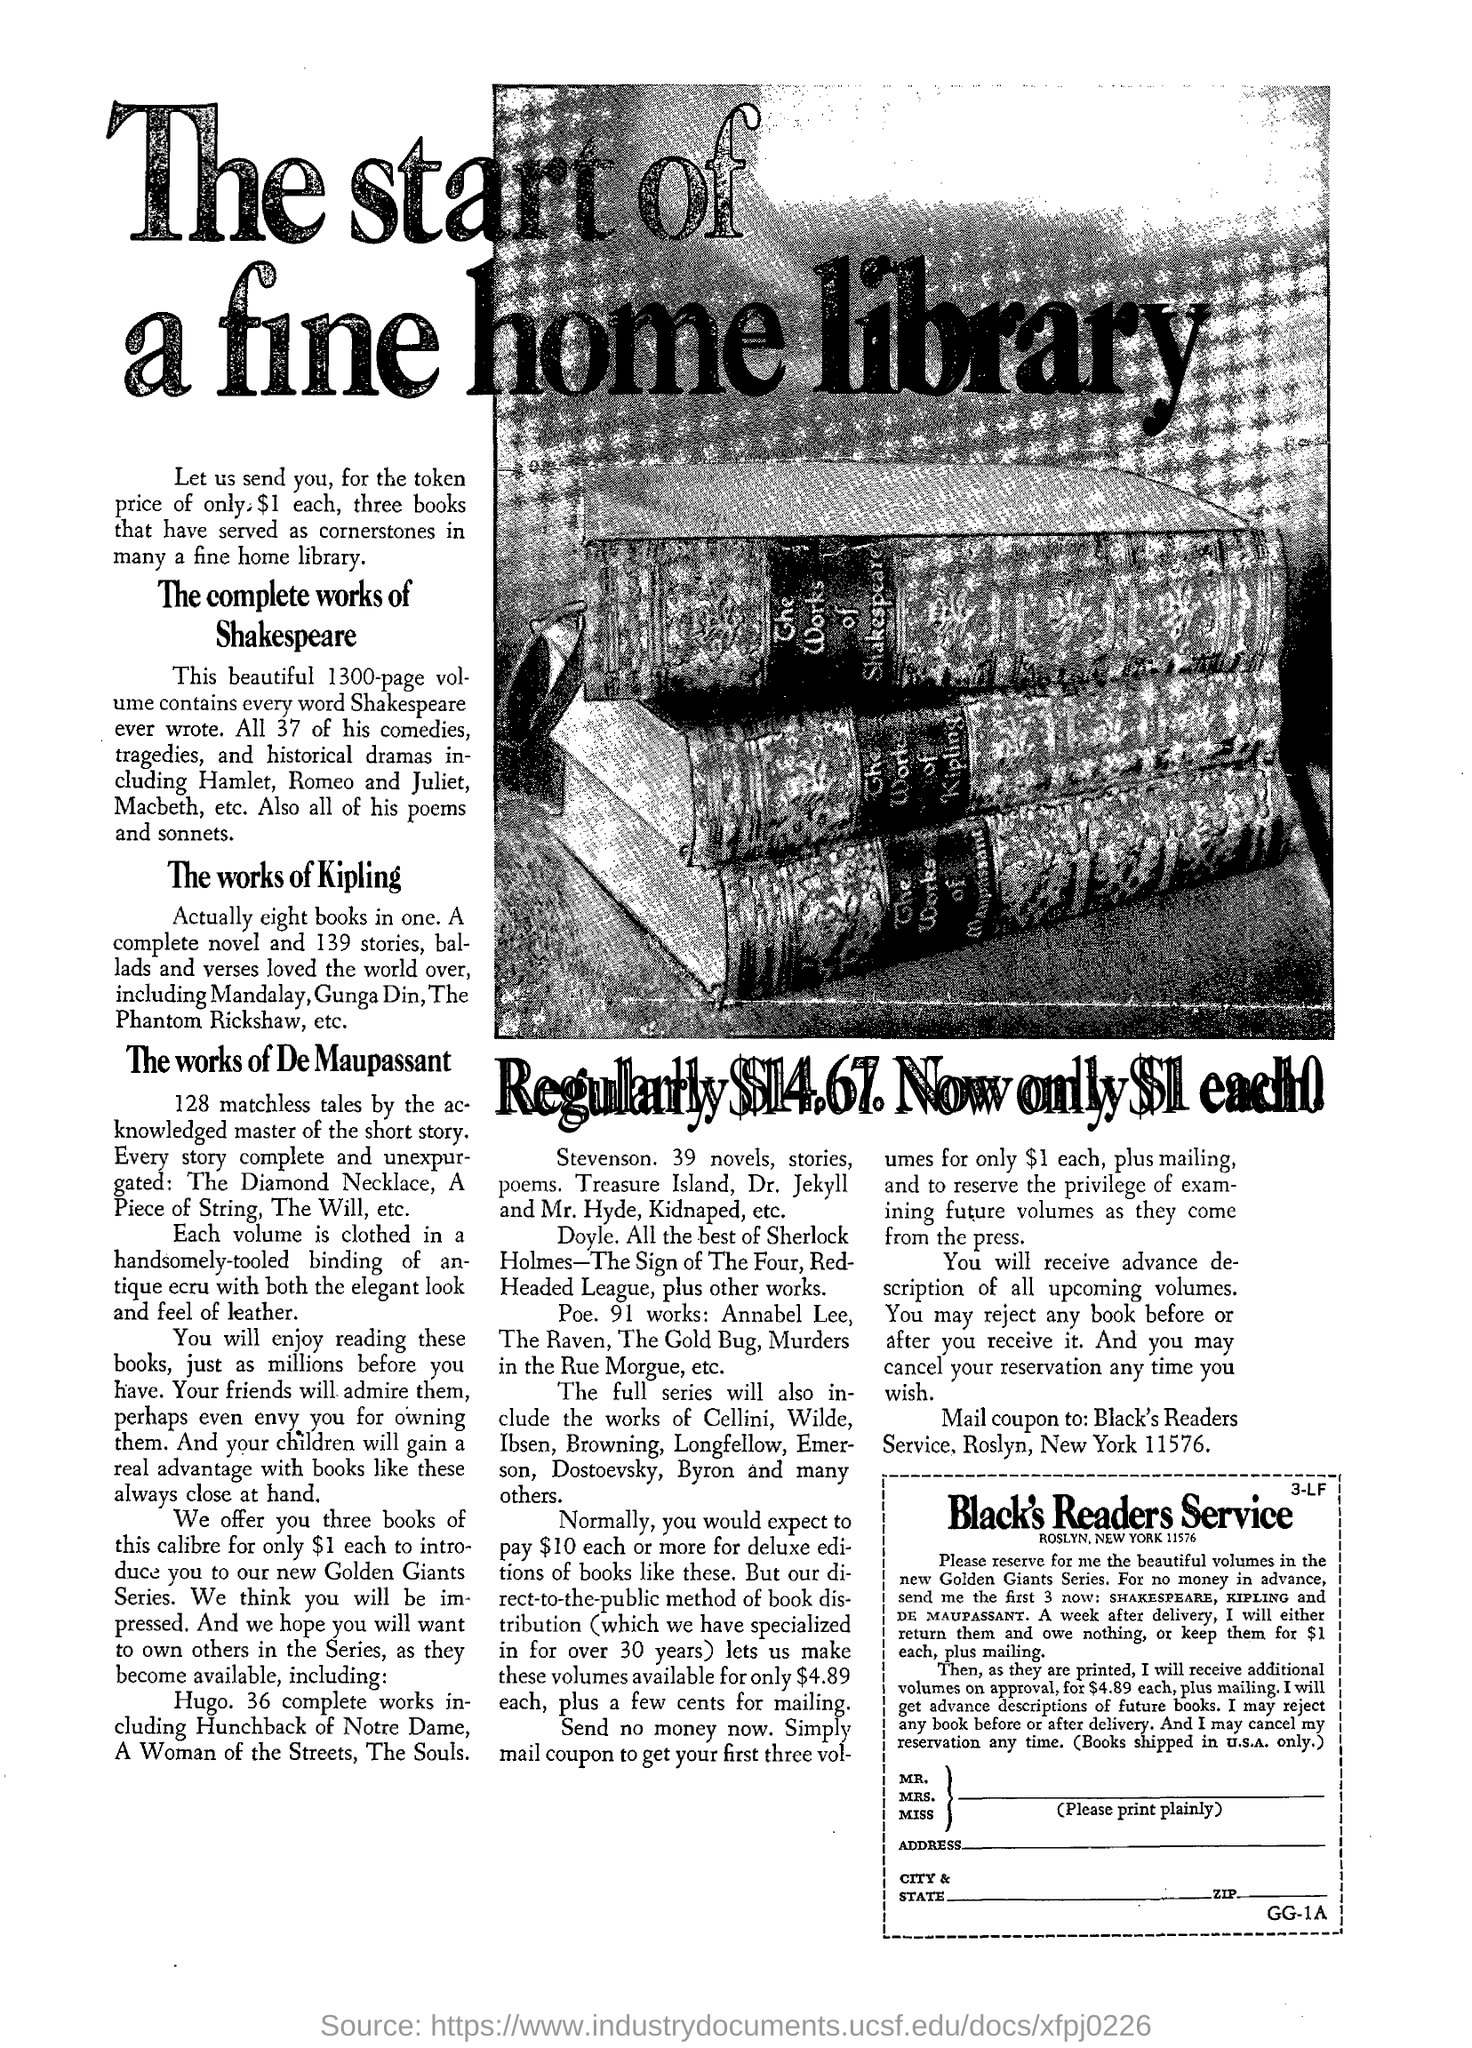Give some essential details in this illustration. The volume contains 1,300 pages. The works of Kipling contain 139 stories. The start of a fine home library is a heading of the document. The price of the token is $1 per token. 